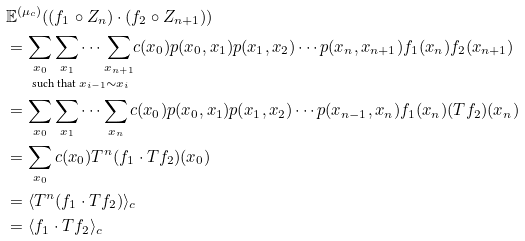<formula> <loc_0><loc_0><loc_500><loc_500>& \mathbb { E } ^ { ( \mu _ { c } ) } ( ( f _ { 1 } \circ Z _ { n } ) \cdot ( f _ { 2 } \circ Z _ { n + 1 } ) ) \\ & = \underset { \text {such that } x _ { i - 1 } \sim x _ { i } } { \sum _ { x _ { 0 } } \sum _ { x _ { 1 } } \cdots \sum _ { x _ { n + 1 } } } c ( x _ { 0 } ) p ( x _ { 0 } , x _ { 1 } ) p ( x _ { 1 } , x _ { 2 } ) \cdots p ( x _ { n } , x _ { n + 1 } ) f _ { 1 } ( x _ { n } ) f _ { 2 } ( x _ { n + 1 } ) \\ & = \sum _ { x _ { 0 } } \sum _ { x _ { 1 } } \cdots \sum _ { x _ { n } } c ( x _ { 0 } ) p ( x _ { 0 } , x _ { 1 } ) p ( x _ { 1 } , x _ { 2 } ) \cdots p ( x _ { n - 1 } , x _ { n } ) f _ { 1 } ( x _ { n } ) ( T f _ { 2 } ) ( x _ { n } ) \\ & = \sum _ { x _ { 0 } } c ( x _ { 0 } ) T ^ { n } ( f _ { 1 } \cdot T f _ { 2 } ) ( x _ { 0 } ) \\ & = \langle T ^ { n } ( f _ { 1 } \cdot T f _ { 2 } ) \rangle _ { c } \\ & = \langle f _ { 1 } \cdot T f _ { 2 } \rangle _ { c }</formula> 